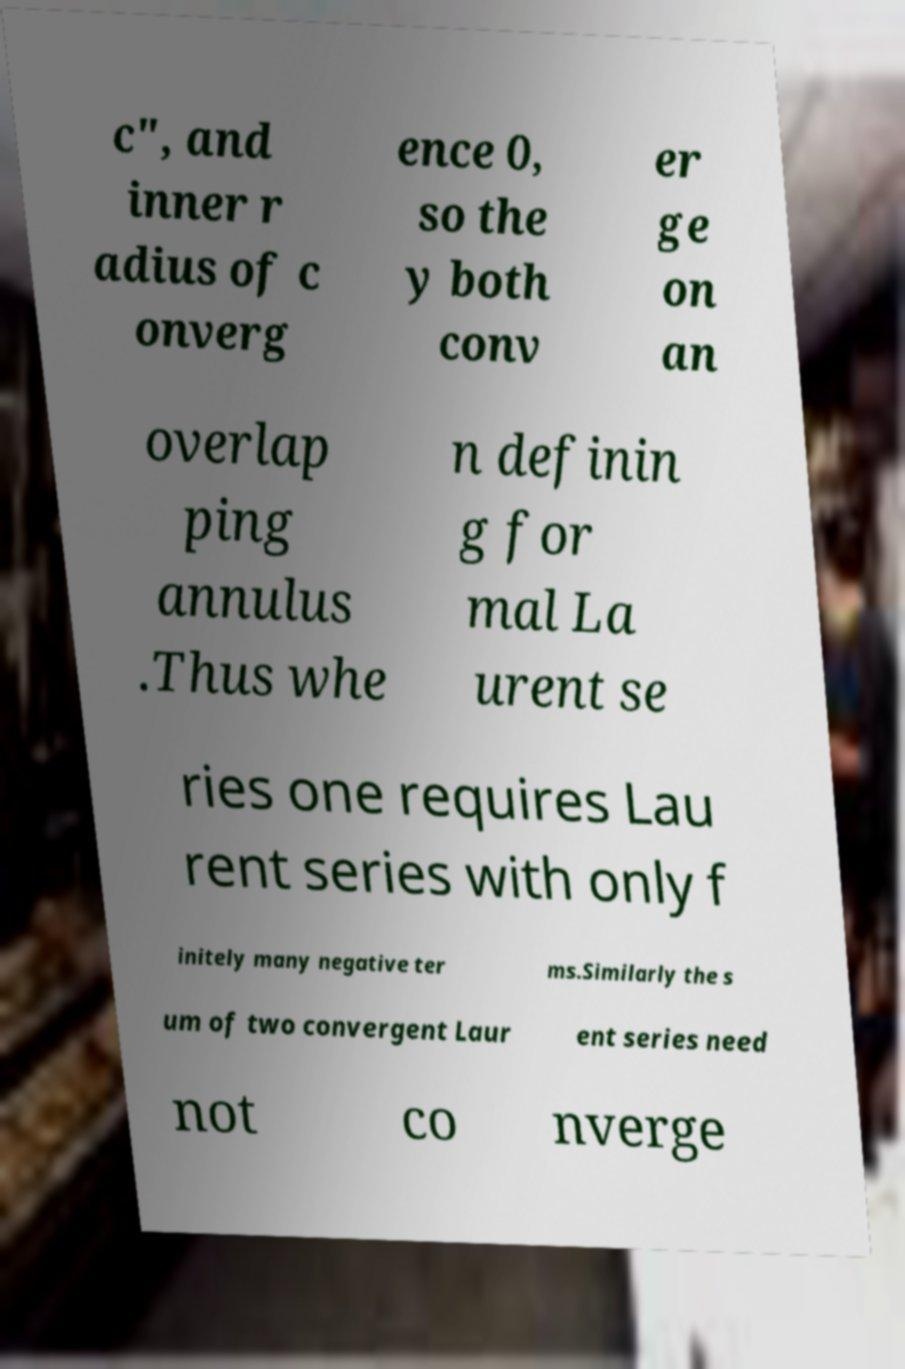Can you accurately transcribe the text from the provided image for me? c", and inner r adius of c onverg ence 0, so the y both conv er ge on an overlap ping annulus .Thus whe n definin g for mal La urent se ries one requires Lau rent series with only f initely many negative ter ms.Similarly the s um of two convergent Laur ent series need not co nverge 